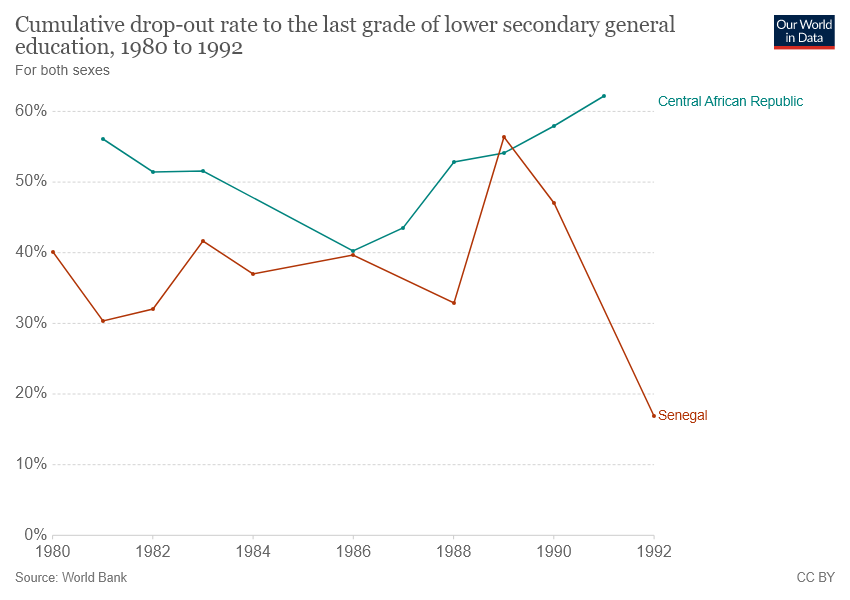Indicate a few pertinent items in this graphic. The country represented by the red color line in the given graph is Senegal. In the year 1992, Senegal experienced the lowest dropout rate among the given years. 